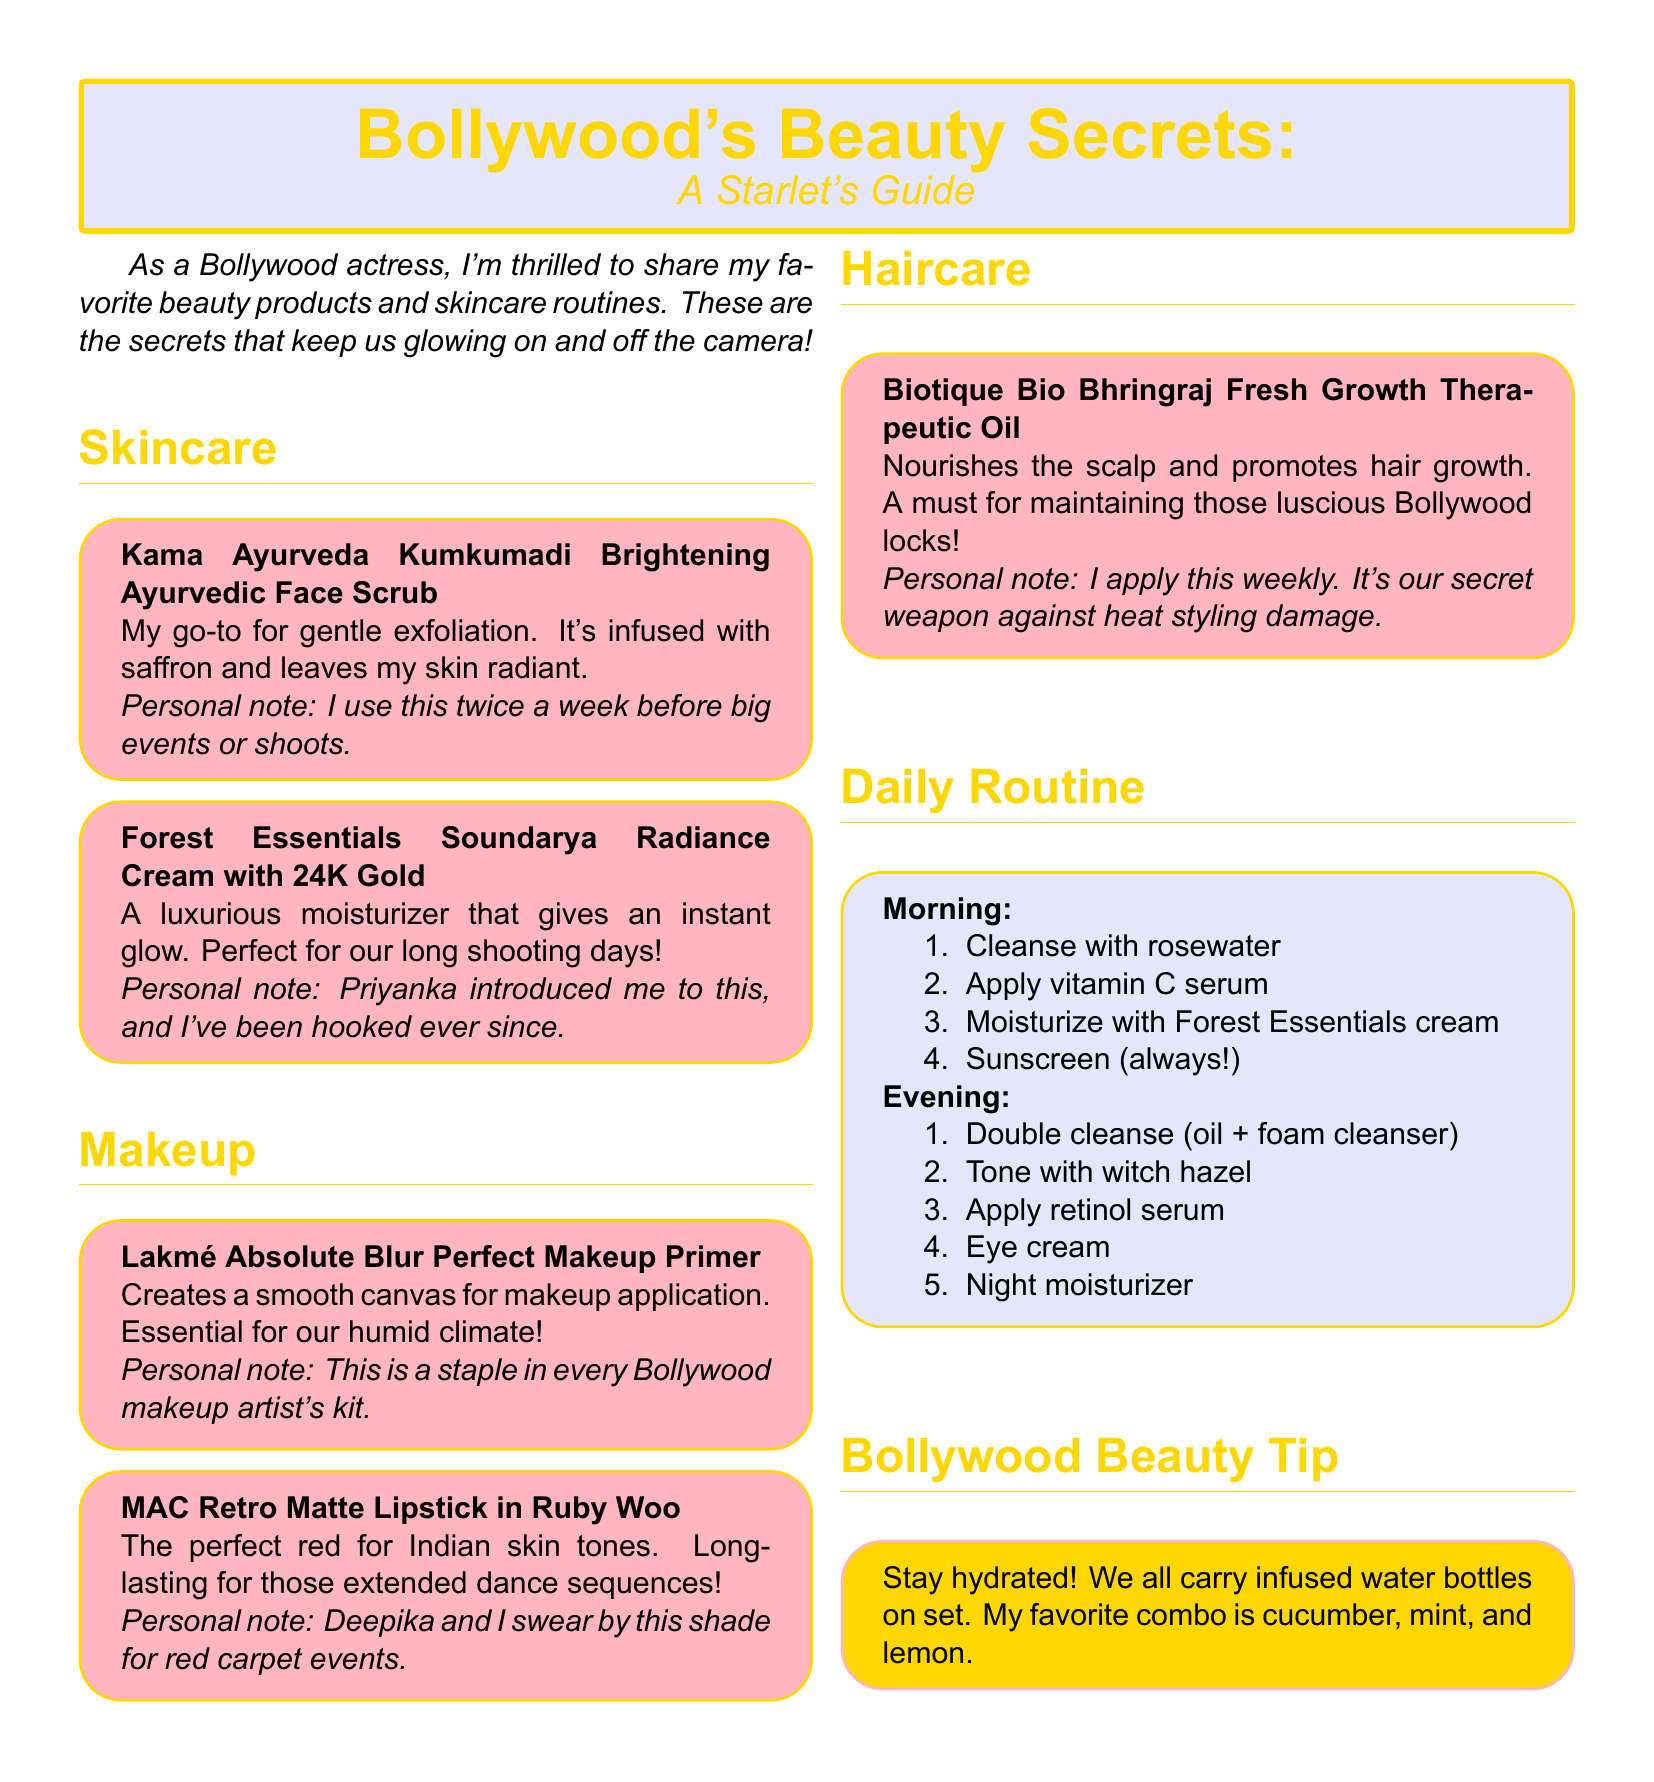What is the name of the face scrub? The face scrub mentioned in the document is named "Kama Ayurveda Kumkumadi Brightening Ayurvedic Face Scrub."
Answer: Kama Ayurveda Kumkumadi Brightening Ayurvedic Face Scrub Who introduced the Forest Essentials cream? The personal note indicates that Priyanka introduced the Forest Essentials cream to the actress.
Answer: Priyanka What is the color of the MAC lipstick mentioned? The specific shade of the MAC lipstick described in the document is "Ruby Woo."
Answer: Ruby Woo How often does the actress use the face scrub? According to the personal note, the actress uses the face scrub twice a week before big events or shoots.
Answer: Twice a week What is one of the ingredients in the infused water recommended? The document mentions cucumber as one of the ingredients for the infused water.
Answer: Cucumber What product is used to create a smooth makeup canvas? The product mentioned for achieving a smooth canvas for makeup application is "Lakmé Absolute Blur Perfect Makeup Primer."
Answer: Lakmé Absolute Blur Perfect Makeup Primer What type of oil is recommended for hair care? The hair care product recommended in the document is "Biotique Bio Bhringraj Fresh Growth Therapeutic Oil."
Answer: Biotique Bio Bhringraj Fresh Growth Therapeutic Oil How many steps are in the morning skincare routine? The morning skincare routine consists of four steps as listed in the document.
Answer: Four steps What color scheme is used for the title box? The title box uses a gold color scheme for the text.
Answer: Gold 